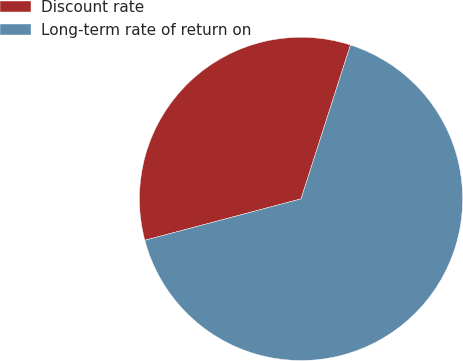Convert chart. <chart><loc_0><loc_0><loc_500><loc_500><pie_chart><fcel>Discount rate<fcel>Long-term rate of return on<nl><fcel>34.07%<fcel>65.93%<nl></chart> 